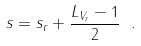Convert formula to latex. <formula><loc_0><loc_0><loc_500><loc_500>s = s _ { r } + \frac { { L } _ { V _ { r } } - 1 } { 2 } \ .</formula> 